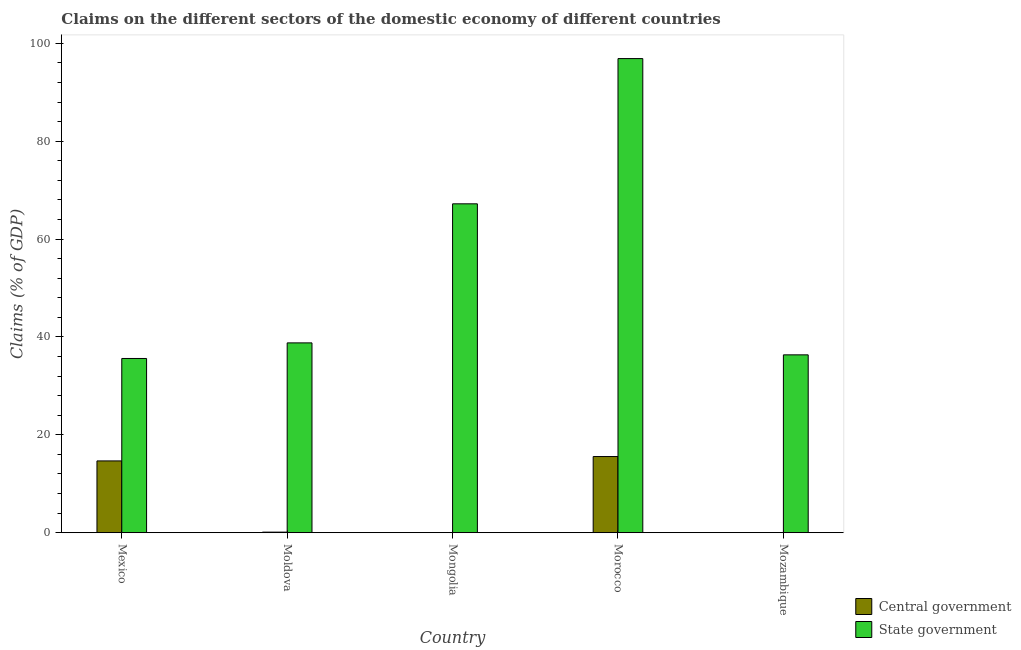Are the number of bars on each tick of the X-axis equal?
Keep it short and to the point. No. How many bars are there on the 3rd tick from the left?
Your answer should be compact. 1. How many bars are there on the 2nd tick from the right?
Provide a short and direct response. 2. What is the label of the 4th group of bars from the left?
Provide a short and direct response. Morocco. Across all countries, what is the maximum claims on central government?
Ensure brevity in your answer.  15.57. Across all countries, what is the minimum claims on central government?
Provide a short and direct response. 0. In which country was the claims on central government maximum?
Give a very brief answer. Morocco. What is the total claims on state government in the graph?
Offer a terse response. 274.87. What is the difference between the claims on central government in Mexico and that in Moldova?
Provide a short and direct response. 14.55. What is the difference between the claims on central government in Mozambique and the claims on state government in Mongolia?
Provide a succinct answer. -67.22. What is the average claims on central government per country?
Provide a succinct answer. 6.07. What is the difference between the claims on central government and claims on state government in Morocco?
Your response must be concise. -81.33. What is the ratio of the claims on state government in Mongolia to that in Mozambique?
Your answer should be compact. 1.85. What is the difference between the highest and the second highest claims on state government?
Your answer should be compact. 29.68. What is the difference between the highest and the lowest claims on central government?
Your answer should be very brief. 15.57. In how many countries, is the claims on state government greater than the average claims on state government taken over all countries?
Ensure brevity in your answer.  2. Is the sum of the claims on state government in Mongolia and Morocco greater than the maximum claims on central government across all countries?
Give a very brief answer. Yes. What is the difference between two consecutive major ticks on the Y-axis?
Your answer should be compact. 20. Where does the legend appear in the graph?
Your response must be concise. Bottom right. How are the legend labels stacked?
Your answer should be very brief. Vertical. What is the title of the graph?
Give a very brief answer. Claims on the different sectors of the domestic economy of different countries. Does "Residents" appear as one of the legend labels in the graph?
Offer a terse response. No. What is the label or title of the Y-axis?
Keep it short and to the point. Claims (% of GDP). What is the Claims (% of GDP) of Central government in Mexico?
Make the answer very short. 14.67. What is the Claims (% of GDP) of State government in Mexico?
Give a very brief answer. 35.61. What is the Claims (% of GDP) in Central government in Moldova?
Your answer should be very brief. 0.12. What is the Claims (% of GDP) of State government in Moldova?
Give a very brief answer. 38.8. What is the Claims (% of GDP) in Central government in Mongolia?
Your response must be concise. 0. What is the Claims (% of GDP) of State government in Mongolia?
Offer a very short reply. 67.22. What is the Claims (% of GDP) of Central government in Morocco?
Your answer should be compact. 15.57. What is the Claims (% of GDP) in State government in Morocco?
Offer a very short reply. 96.9. What is the Claims (% of GDP) in Central government in Mozambique?
Keep it short and to the point. 0. What is the Claims (% of GDP) in State government in Mozambique?
Keep it short and to the point. 36.35. Across all countries, what is the maximum Claims (% of GDP) of Central government?
Provide a short and direct response. 15.57. Across all countries, what is the maximum Claims (% of GDP) of State government?
Make the answer very short. 96.9. Across all countries, what is the minimum Claims (% of GDP) in Central government?
Give a very brief answer. 0. Across all countries, what is the minimum Claims (% of GDP) in State government?
Offer a very short reply. 35.61. What is the total Claims (% of GDP) of Central government in the graph?
Provide a succinct answer. 30.36. What is the total Claims (% of GDP) of State government in the graph?
Make the answer very short. 274.87. What is the difference between the Claims (% of GDP) in Central government in Mexico and that in Moldova?
Give a very brief answer. 14.55. What is the difference between the Claims (% of GDP) of State government in Mexico and that in Moldova?
Provide a succinct answer. -3.19. What is the difference between the Claims (% of GDP) in State government in Mexico and that in Mongolia?
Make the answer very short. -31.61. What is the difference between the Claims (% of GDP) in Central government in Mexico and that in Morocco?
Provide a succinct answer. -0.9. What is the difference between the Claims (% of GDP) of State government in Mexico and that in Morocco?
Your answer should be compact. -61.29. What is the difference between the Claims (% of GDP) in State government in Mexico and that in Mozambique?
Keep it short and to the point. -0.74. What is the difference between the Claims (% of GDP) in State government in Moldova and that in Mongolia?
Offer a very short reply. -28.42. What is the difference between the Claims (% of GDP) of Central government in Moldova and that in Morocco?
Ensure brevity in your answer.  -15.45. What is the difference between the Claims (% of GDP) of State government in Moldova and that in Morocco?
Make the answer very short. -58.1. What is the difference between the Claims (% of GDP) of State government in Moldova and that in Mozambique?
Your answer should be very brief. 2.45. What is the difference between the Claims (% of GDP) in State government in Mongolia and that in Morocco?
Provide a succinct answer. -29.68. What is the difference between the Claims (% of GDP) in State government in Mongolia and that in Mozambique?
Provide a succinct answer. 30.87. What is the difference between the Claims (% of GDP) in State government in Morocco and that in Mozambique?
Offer a very short reply. 60.55. What is the difference between the Claims (% of GDP) in Central government in Mexico and the Claims (% of GDP) in State government in Moldova?
Give a very brief answer. -24.12. What is the difference between the Claims (% of GDP) in Central government in Mexico and the Claims (% of GDP) in State government in Mongolia?
Your answer should be very brief. -52.54. What is the difference between the Claims (% of GDP) in Central government in Mexico and the Claims (% of GDP) in State government in Morocco?
Keep it short and to the point. -82.23. What is the difference between the Claims (% of GDP) of Central government in Mexico and the Claims (% of GDP) of State government in Mozambique?
Give a very brief answer. -21.68. What is the difference between the Claims (% of GDP) of Central government in Moldova and the Claims (% of GDP) of State government in Mongolia?
Offer a terse response. -67.1. What is the difference between the Claims (% of GDP) of Central government in Moldova and the Claims (% of GDP) of State government in Morocco?
Offer a terse response. -96.78. What is the difference between the Claims (% of GDP) in Central government in Moldova and the Claims (% of GDP) in State government in Mozambique?
Keep it short and to the point. -36.23. What is the difference between the Claims (% of GDP) in Central government in Morocco and the Claims (% of GDP) in State government in Mozambique?
Provide a succinct answer. -20.78. What is the average Claims (% of GDP) in Central government per country?
Your answer should be compact. 6.07. What is the average Claims (% of GDP) of State government per country?
Your answer should be compact. 54.97. What is the difference between the Claims (% of GDP) in Central government and Claims (% of GDP) in State government in Mexico?
Make the answer very short. -20.94. What is the difference between the Claims (% of GDP) in Central government and Claims (% of GDP) in State government in Moldova?
Make the answer very short. -38.68. What is the difference between the Claims (% of GDP) of Central government and Claims (% of GDP) of State government in Morocco?
Offer a very short reply. -81.33. What is the ratio of the Claims (% of GDP) of Central government in Mexico to that in Moldova?
Offer a terse response. 122.87. What is the ratio of the Claims (% of GDP) in State government in Mexico to that in Moldova?
Your answer should be very brief. 0.92. What is the ratio of the Claims (% of GDP) in State government in Mexico to that in Mongolia?
Your answer should be very brief. 0.53. What is the ratio of the Claims (% of GDP) in Central government in Mexico to that in Morocco?
Provide a succinct answer. 0.94. What is the ratio of the Claims (% of GDP) in State government in Mexico to that in Morocco?
Give a very brief answer. 0.37. What is the ratio of the Claims (% of GDP) of State government in Mexico to that in Mozambique?
Offer a terse response. 0.98. What is the ratio of the Claims (% of GDP) of State government in Moldova to that in Mongolia?
Provide a succinct answer. 0.58. What is the ratio of the Claims (% of GDP) in Central government in Moldova to that in Morocco?
Your response must be concise. 0.01. What is the ratio of the Claims (% of GDP) of State government in Moldova to that in Morocco?
Offer a terse response. 0.4. What is the ratio of the Claims (% of GDP) in State government in Moldova to that in Mozambique?
Keep it short and to the point. 1.07. What is the ratio of the Claims (% of GDP) in State government in Mongolia to that in Morocco?
Make the answer very short. 0.69. What is the ratio of the Claims (% of GDP) in State government in Mongolia to that in Mozambique?
Provide a succinct answer. 1.85. What is the ratio of the Claims (% of GDP) in State government in Morocco to that in Mozambique?
Your answer should be compact. 2.67. What is the difference between the highest and the second highest Claims (% of GDP) in Central government?
Make the answer very short. 0.9. What is the difference between the highest and the second highest Claims (% of GDP) in State government?
Keep it short and to the point. 29.68. What is the difference between the highest and the lowest Claims (% of GDP) of Central government?
Keep it short and to the point. 15.57. What is the difference between the highest and the lowest Claims (% of GDP) in State government?
Provide a succinct answer. 61.29. 